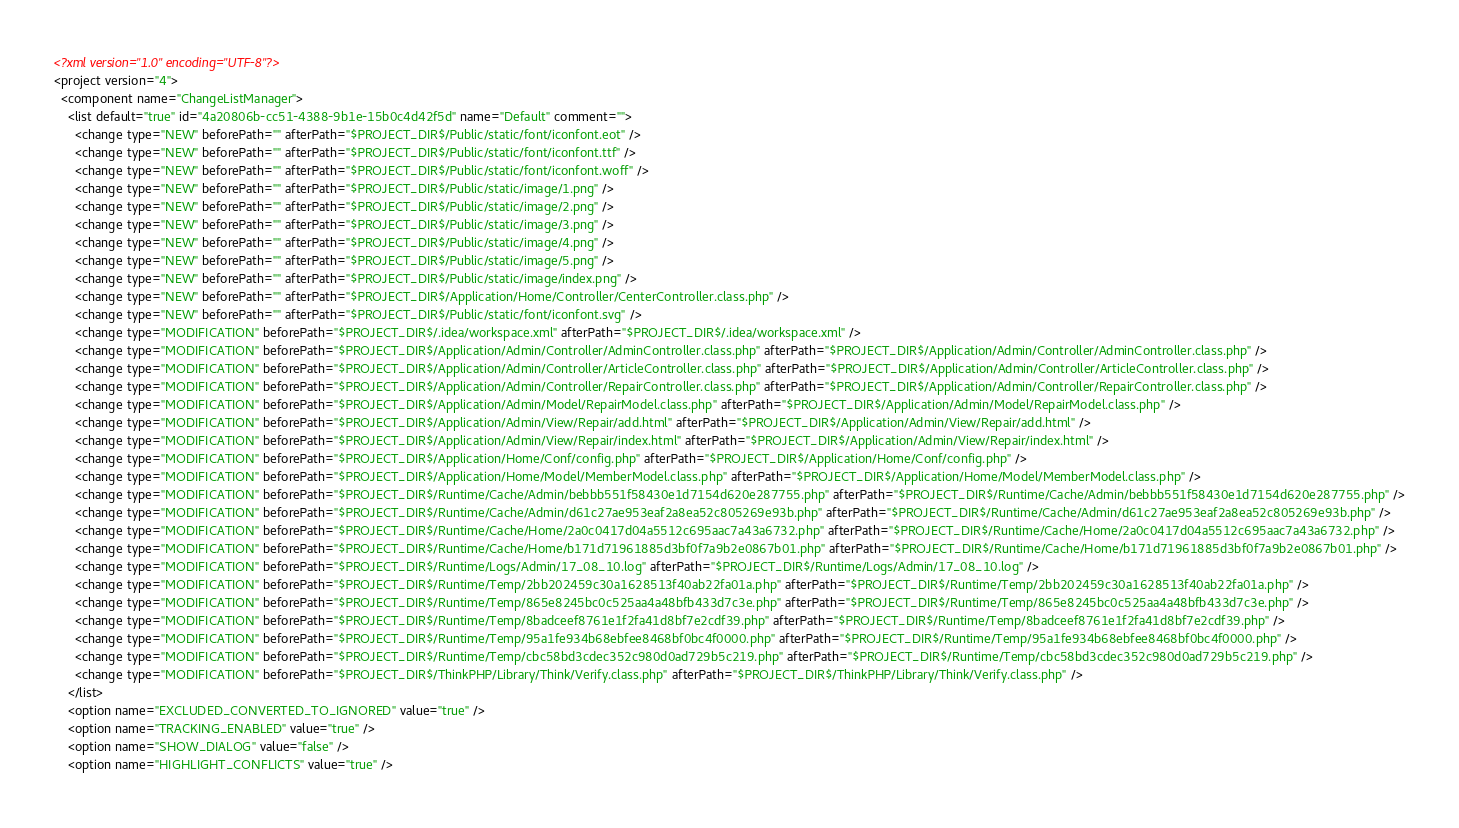Convert code to text. <code><loc_0><loc_0><loc_500><loc_500><_XML_><?xml version="1.0" encoding="UTF-8"?>
<project version="4">
  <component name="ChangeListManager">
    <list default="true" id="4a20806b-cc51-4388-9b1e-15b0c4d42f5d" name="Default" comment="">
      <change type="NEW" beforePath="" afterPath="$PROJECT_DIR$/Public/static/font/iconfont.eot" />
      <change type="NEW" beforePath="" afterPath="$PROJECT_DIR$/Public/static/font/iconfont.ttf" />
      <change type="NEW" beforePath="" afterPath="$PROJECT_DIR$/Public/static/font/iconfont.woff" />
      <change type="NEW" beforePath="" afterPath="$PROJECT_DIR$/Public/static/image/1.png" />
      <change type="NEW" beforePath="" afterPath="$PROJECT_DIR$/Public/static/image/2.png" />
      <change type="NEW" beforePath="" afterPath="$PROJECT_DIR$/Public/static/image/3.png" />
      <change type="NEW" beforePath="" afterPath="$PROJECT_DIR$/Public/static/image/4.png" />
      <change type="NEW" beforePath="" afterPath="$PROJECT_DIR$/Public/static/image/5.png" />
      <change type="NEW" beforePath="" afterPath="$PROJECT_DIR$/Public/static/image/index.png" />
      <change type="NEW" beforePath="" afterPath="$PROJECT_DIR$/Application/Home/Controller/CenterController.class.php" />
      <change type="NEW" beforePath="" afterPath="$PROJECT_DIR$/Public/static/font/iconfont.svg" />
      <change type="MODIFICATION" beforePath="$PROJECT_DIR$/.idea/workspace.xml" afterPath="$PROJECT_DIR$/.idea/workspace.xml" />
      <change type="MODIFICATION" beforePath="$PROJECT_DIR$/Application/Admin/Controller/AdminController.class.php" afterPath="$PROJECT_DIR$/Application/Admin/Controller/AdminController.class.php" />
      <change type="MODIFICATION" beforePath="$PROJECT_DIR$/Application/Admin/Controller/ArticleController.class.php" afterPath="$PROJECT_DIR$/Application/Admin/Controller/ArticleController.class.php" />
      <change type="MODIFICATION" beforePath="$PROJECT_DIR$/Application/Admin/Controller/RepairController.class.php" afterPath="$PROJECT_DIR$/Application/Admin/Controller/RepairController.class.php" />
      <change type="MODIFICATION" beforePath="$PROJECT_DIR$/Application/Admin/Model/RepairModel.class.php" afterPath="$PROJECT_DIR$/Application/Admin/Model/RepairModel.class.php" />
      <change type="MODIFICATION" beforePath="$PROJECT_DIR$/Application/Admin/View/Repair/add.html" afterPath="$PROJECT_DIR$/Application/Admin/View/Repair/add.html" />
      <change type="MODIFICATION" beforePath="$PROJECT_DIR$/Application/Admin/View/Repair/index.html" afterPath="$PROJECT_DIR$/Application/Admin/View/Repair/index.html" />
      <change type="MODIFICATION" beforePath="$PROJECT_DIR$/Application/Home/Conf/config.php" afterPath="$PROJECT_DIR$/Application/Home/Conf/config.php" />
      <change type="MODIFICATION" beforePath="$PROJECT_DIR$/Application/Home/Model/MemberModel.class.php" afterPath="$PROJECT_DIR$/Application/Home/Model/MemberModel.class.php" />
      <change type="MODIFICATION" beforePath="$PROJECT_DIR$/Runtime/Cache/Admin/bebbb551f58430e1d7154d620e287755.php" afterPath="$PROJECT_DIR$/Runtime/Cache/Admin/bebbb551f58430e1d7154d620e287755.php" />
      <change type="MODIFICATION" beforePath="$PROJECT_DIR$/Runtime/Cache/Admin/d61c27ae953eaf2a8ea52c805269e93b.php" afterPath="$PROJECT_DIR$/Runtime/Cache/Admin/d61c27ae953eaf2a8ea52c805269e93b.php" />
      <change type="MODIFICATION" beforePath="$PROJECT_DIR$/Runtime/Cache/Home/2a0c0417d04a5512c695aac7a43a6732.php" afterPath="$PROJECT_DIR$/Runtime/Cache/Home/2a0c0417d04a5512c695aac7a43a6732.php" />
      <change type="MODIFICATION" beforePath="$PROJECT_DIR$/Runtime/Cache/Home/b171d71961885d3bf0f7a9b2e0867b01.php" afterPath="$PROJECT_DIR$/Runtime/Cache/Home/b171d71961885d3bf0f7a9b2e0867b01.php" />
      <change type="MODIFICATION" beforePath="$PROJECT_DIR$/Runtime/Logs/Admin/17_08_10.log" afterPath="$PROJECT_DIR$/Runtime/Logs/Admin/17_08_10.log" />
      <change type="MODIFICATION" beforePath="$PROJECT_DIR$/Runtime/Temp/2bb202459c30a1628513f40ab22fa01a.php" afterPath="$PROJECT_DIR$/Runtime/Temp/2bb202459c30a1628513f40ab22fa01a.php" />
      <change type="MODIFICATION" beforePath="$PROJECT_DIR$/Runtime/Temp/865e8245bc0c525aa4a48bfb433d7c3e.php" afterPath="$PROJECT_DIR$/Runtime/Temp/865e8245bc0c525aa4a48bfb433d7c3e.php" />
      <change type="MODIFICATION" beforePath="$PROJECT_DIR$/Runtime/Temp/8badceef8761e1f2fa41d8bf7e2cdf39.php" afterPath="$PROJECT_DIR$/Runtime/Temp/8badceef8761e1f2fa41d8bf7e2cdf39.php" />
      <change type="MODIFICATION" beforePath="$PROJECT_DIR$/Runtime/Temp/95a1fe934b68ebfee8468bf0bc4f0000.php" afterPath="$PROJECT_DIR$/Runtime/Temp/95a1fe934b68ebfee8468bf0bc4f0000.php" />
      <change type="MODIFICATION" beforePath="$PROJECT_DIR$/Runtime/Temp/cbc58bd3cdec352c980d0ad729b5c219.php" afterPath="$PROJECT_DIR$/Runtime/Temp/cbc58bd3cdec352c980d0ad729b5c219.php" />
      <change type="MODIFICATION" beforePath="$PROJECT_DIR$/ThinkPHP/Library/Think/Verify.class.php" afterPath="$PROJECT_DIR$/ThinkPHP/Library/Think/Verify.class.php" />
    </list>
    <option name="EXCLUDED_CONVERTED_TO_IGNORED" value="true" />
    <option name="TRACKING_ENABLED" value="true" />
    <option name="SHOW_DIALOG" value="false" />
    <option name="HIGHLIGHT_CONFLICTS" value="true" /></code> 